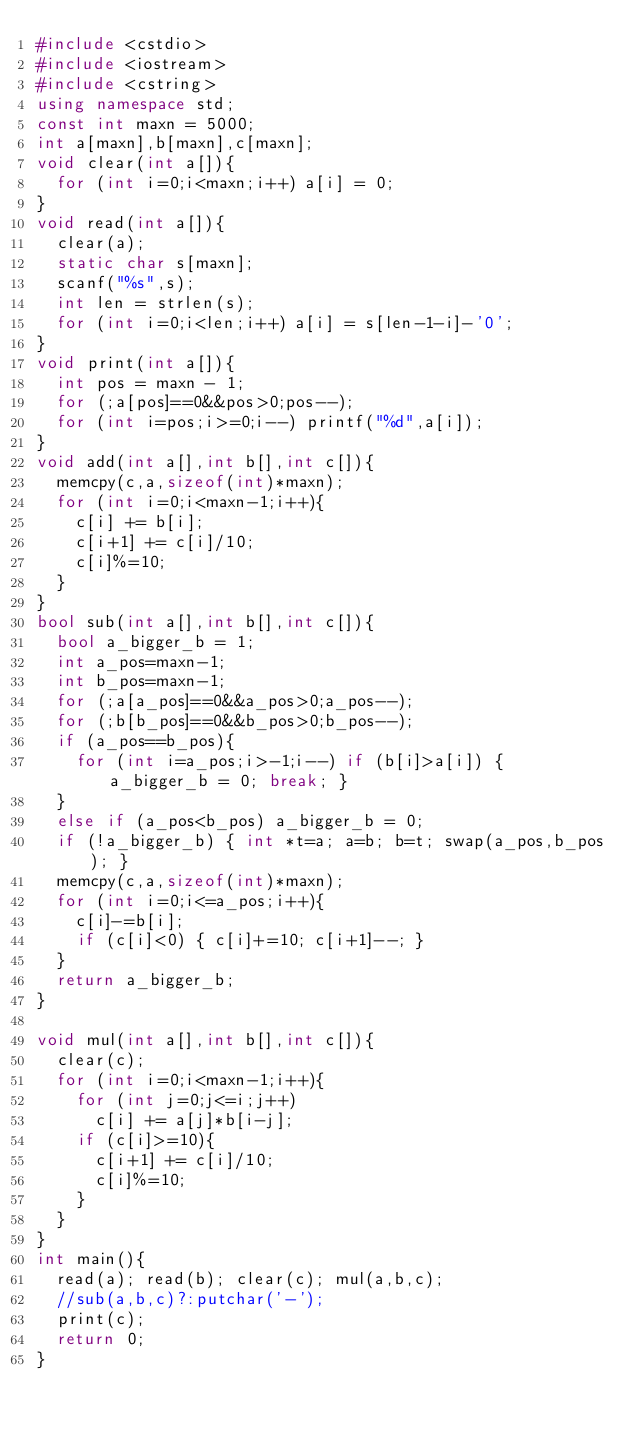Convert code to text. <code><loc_0><loc_0><loc_500><loc_500><_C++_>#include <cstdio>
#include <iostream> 
#include <cstring>
using namespace std;
const int maxn = 5000;
int a[maxn],b[maxn],c[maxn];
void clear(int a[]){
  for (int i=0;i<maxn;i++) a[i] = 0;
}
void read(int a[]){
  clear(a);
  static char s[maxn];
  scanf("%s",s);
  int len = strlen(s);
  for (int i=0;i<len;i++) a[i] = s[len-1-i]-'0';
}
void print(int a[]){
  int pos = maxn - 1;
  for (;a[pos]==0&&pos>0;pos--);
  for (int i=pos;i>=0;i--) printf("%d",a[i]);
}
void add(int a[],int b[],int c[]){
  memcpy(c,a,sizeof(int)*maxn);
  for (int i=0;i<maxn-1;i++){
    c[i] += b[i];
    c[i+1] += c[i]/10;
    c[i]%=10;
  }
}
bool sub(int a[],int b[],int c[]){
  bool a_bigger_b = 1;
  int a_pos=maxn-1;
  int b_pos=maxn-1;
  for (;a[a_pos]==0&&a_pos>0;a_pos--);
  for (;b[b_pos]==0&&b_pos>0;b_pos--);
  if (a_pos==b_pos){
    for (int i=a_pos;i>-1;i--) if (b[i]>a[i]) { a_bigger_b = 0; break; }
  }
  else if (a_pos<b_pos) a_bigger_b = 0;
  if (!a_bigger_b) { int *t=a; a=b; b=t; swap(a_pos,b_pos); }
  memcpy(c,a,sizeof(int)*maxn);
  for (int i=0;i<=a_pos;i++){
    c[i]-=b[i];
    if (c[i]<0) { c[i]+=10; c[i+1]--; }
  }
  return a_bigger_b;
}

void mul(int a[],int b[],int c[]){
  clear(c);
  for (int i=0;i<maxn-1;i++){
    for (int j=0;j<=i;j++)
      c[i] += a[j]*b[i-j];
    if (c[i]>=10){
      c[i+1] += c[i]/10;
      c[i]%=10;
    }
  }
}
int main(){
  read(a); read(b); clear(c); mul(a,b,c);
  //sub(a,b,c)?:putchar('-'); 
  print(c);
  return 0;
}</code> 